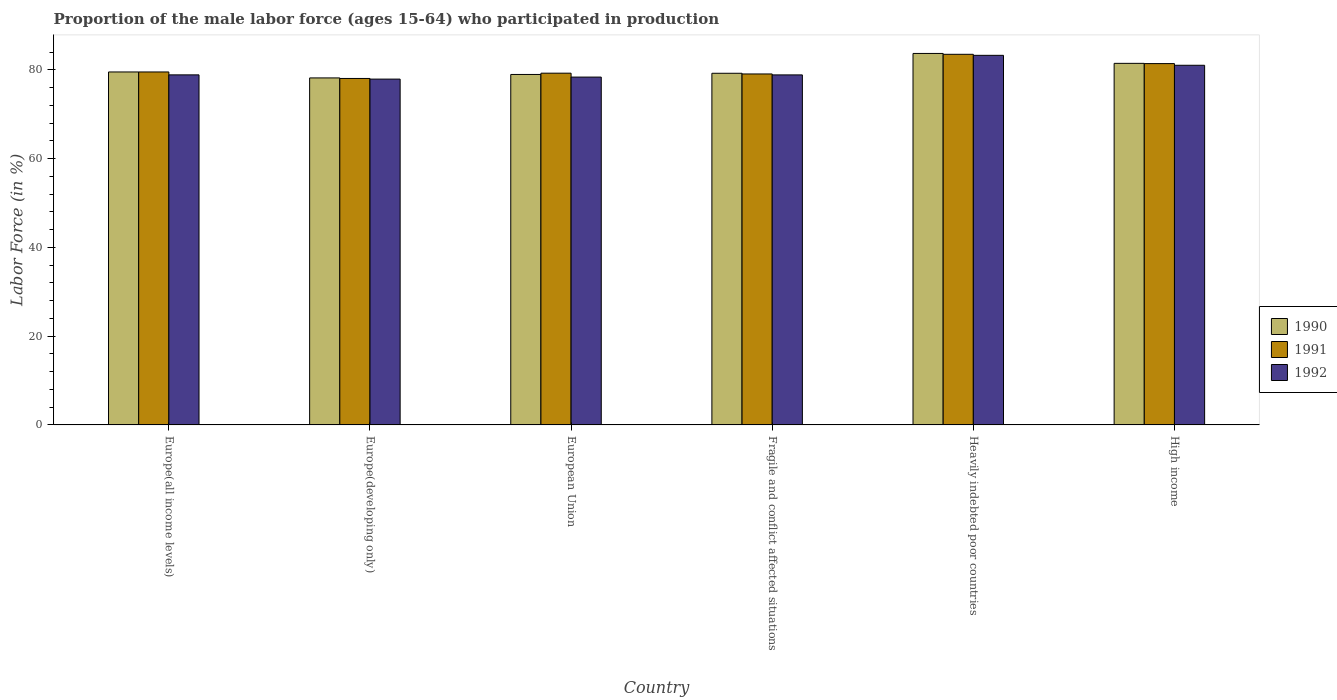Are the number of bars on each tick of the X-axis equal?
Ensure brevity in your answer.  Yes. What is the label of the 1st group of bars from the left?
Offer a very short reply. Europe(all income levels). What is the proportion of the male labor force who participated in production in 1991 in High income?
Your answer should be very brief. 81.39. Across all countries, what is the maximum proportion of the male labor force who participated in production in 1991?
Your answer should be very brief. 83.49. Across all countries, what is the minimum proportion of the male labor force who participated in production in 1992?
Give a very brief answer. 77.9. In which country was the proportion of the male labor force who participated in production in 1991 maximum?
Your response must be concise. Heavily indebted poor countries. In which country was the proportion of the male labor force who participated in production in 1991 minimum?
Your answer should be compact. Europe(developing only). What is the total proportion of the male labor force who participated in production in 1992 in the graph?
Keep it short and to the point. 478.23. What is the difference between the proportion of the male labor force who participated in production in 1990 in Europe(developing only) and that in European Union?
Your answer should be compact. -0.78. What is the difference between the proportion of the male labor force who participated in production in 1991 in Fragile and conflict affected situations and the proportion of the male labor force who participated in production in 1990 in Europe(all income levels)?
Your answer should be compact. -0.45. What is the average proportion of the male labor force who participated in production in 1991 per country?
Your answer should be compact. 80.12. What is the difference between the proportion of the male labor force who participated in production of/in 1991 and proportion of the male labor force who participated in production of/in 1992 in High income?
Provide a short and direct response. 0.38. What is the ratio of the proportion of the male labor force who participated in production in 1991 in European Union to that in Heavily indebted poor countries?
Your answer should be very brief. 0.95. What is the difference between the highest and the second highest proportion of the male labor force who participated in production in 1991?
Offer a very short reply. -2.09. What is the difference between the highest and the lowest proportion of the male labor force who participated in production in 1990?
Give a very brief answer. 5.51. Is the sum of the proportion of the male labor force who participated in production in 1991 in Europe(developing only) and High income greater than the maximum proportion of the male labor force who participated in production in 1992 across all countries?
Your answer should be very brief. Yes. What does the 2nd bar from the left in High income represents?
Keep it short and to the point. 1991. What does the 1st bar from the right in Europe(developing only) represents?
Make the answer very short. 1992. Is it the case that in every country, the sum of the proportion of the male labor force who participated in production in 1991 and proportion of the male labor force who participated in production in 1990 is greater than the proportion of the male labor force who participated in production in 1992?
Offer a terse response. Yes. How many bars are there?
Keep it short and to the point. 18. How many countries are there in the graph?
Offer a very short reply. 6. What is the difference between two consecutive major ticks on the Y-axis?
Keep it short and to the point. 20. Does the graph contain any zero values?
Offer a terse response. No. How many legend labels are there?
Your response must be concise. 3. How are the legend labels stacked?
Ensure brevity in your answer.  Vertical. What is the title of the graph?
Give a very brief answer. Proportion of the male labor force (ages 15-64) who participated in production. Does "1969" appear as one of the legend labels in the graph?
Your response must be concise. No. What is the Labor Force (in %) in 1990 in Europe(all income levels)?
Offer a very short reply. 79.51. What is the Labor Force (in %) in 1991 in Europe(all income levels)?
Your answer should be compact. 79.51. What is the Labor Force (in %) in 1992 in Europe(all income levels)?
Keep it short and to the point. 78.85. What is the Labor Force (in %) of 1990 in Europe(developing only)?
Keep it short and to the point. 78.17. What is the Labor Force (in %) in 1991 in Europe(developing only)?
Your answer should be very brief. 78.05. What is the Labor Force (in %) of 1992 in Europe(developing only)?
Keep it short and to the point. 77.9. What is the Labor Force (in %) of 1990 in European Union?
Your response must be concise. 78.95. What is the Labor Force (in %) of 1991 in European Union?
Your answer should be very brief. 79.24. What is the Labor Force (in %) in 1992 in European Union?
Offer a terse response. 78.36. What is the Labor Force (in %) of 1990 in Fragile and conflict affected situations?
Give a very brief answer. 79.22. What is the Labor Force (in %) in 1991 in Fragile and conflict affected situations?
Provide a succinct answer. 79.06. What is the Labor Force (in %) of 1992 in Fragile and conflict affected situations?
Offer a terse response. 78.85. What is the Labor Force (in %) in 1990 in Heavily indebted poor countries?
Ensure brevity in your answer.  83.68. What is the Labor Force (in %) of 1991 in Heavily indebted poor countries?
Offer a very short reply. 83.49. What is the Labor Force (in %) of 1992 in Heavily indebted poor countries?
Offer a terse response. 83.25. What is the Labor Force (in %) of 1990 in High income?
Give a very brief answer. 81.45. What is the Labor Force (in %) in 1991 in High income?
Your response must be concise. 81.39. What is the Labor Force (in %) in 1992 in High income?
Your response must be concise. 81.02. Across all countries, what is the maximum Labor Force (in %) in 1990?
Provide a succinct answer. 83.68. Across all countries, what is the maximum Labor Force (in %) in 1991?
Your answer should be very brief. 83.49. Across all countries, what is the maximum Labor Force (in %) in 1992?
Offer a very short reply. 83.25. Across all countries, what is the minimum Labor Force (in %) of 1990?
Keep it short and to the point. 78.17. Across all countries, what is the minimum Labor Force (in %) of 1991?
Your answer should be compact. 78.05. Across all countries, what is the minimum Labor Force (in %) of 1992?
Provide a succinct answer. 77.9. What is the total Labor Force (in %) in 1990 in the graph?
Your response must be concise. 480.98. What is the total Labor Force (in %) in 1991 in the graph?
Ensure brevity in your answer.  480.74. What is the total Labor Force (in %) in 1992 in the graph?
Ensure brevity in your answer.  478.23. What is the difference between the Labor Force (in %) in 1990 in Europe(all income levels) and that in Europe(developing only)?
Provide a short and direct response. 1.34. What is the difference between the Labor Force (in %) of 1991 in Europe(all income levels) and that in Europe(developing only)?
Your response must be concise. 1.46. What is the difference between the Labor Force (in %) of 1992 in Europe(all income levels) and that in Europe(developing only)?
Provide a short and direct response. 0.95. What is the difference between the Labor Force (in %) of 1990 in Europe(all income levels) and that in European Union?
Keep it short and to the point. 0.56. What is the difference between the Labor Force (in %) of 1991 in Europe(all income levels) and that in European Union?
Offer a very short reply. 0.27. What is the difference between the Labor Force (in %) in 1992 in Europe(all income levels) and that in European Union?
Keep it short and to the point. 0.5. What is the difference between the Labor Force (in %) in 1990 in Europe(all income levels) and that in Fragile and conflict affected situations?
Make the answer very short. 0.3. What is the difference between the Labor Force (in %) in 1991 in Europe(all income levels) and that in Fragile and conflict affected situations?
Your answer should be compact. 0.45. What is the difference between the Labor Force (in %) of 1992 in Europe(all income levels) and that in Fragile and conflict affected situations?
Provide a short and direct response. 0.01. What is the difference between the Labor Force (in %) in 1990 in Europe(all income levels) and that in Heavily indebted poor countries?
Provide a short and direct response. -4.17. What is the difference between the Labor Force (in %) of 1991 in Europe(all income levels) and that in Heavily indebted poor countries?
Offer a very short reply. -3.98. What is the difference between the Labor Force (in %) in 1992 in Europe(all income levels) and that in Heavily indebted poor countries?
Give a very brief answer. -4.4. What is the difference between the Labor Force (in %) of 1990 in Europe(all income levels) and that in High income?
Give a very brief answer. -1.94. What is the difference between the Labor Force (in %) of 1991 in Europe(all income levels) and that in High income?
Offer a terse response. -1.89. What is the difference between the Labor Force (in %) in 1992 in Europe(all income levels) and that in High income?
Provide a short and direct response. -2.16. What is the difference between the Labor Force (in %) in 1990 in Europe(developing only) and that in European Union?
Provide a succinct answer. -0.78. What is the difference between the Labor Force (in %) of 1991 in Europe(developing only) and that in European Union?
Your answer should be compact. -1.19. What is the difference between the Labor Force (in %) of 1992 in Europe(developing only) and that in European Union?
Ensure brevity in your answer.  -0.45. What is the difference between the Labor Force (in %) in 1990 in Europe(developing only) and that in Fragile and conflict affected situations?
Make the answer very short. -1.05. What is the difference between the Labor Force (in %) in 1991 in Europe(developing only) and that in Fragile and conflict affected situations?
Offer a terse response. -1.01. What is the difference between the Labor Force (in %) in 1992 in Europe(developing only) and that in Fragile and conflict affected situations?
Ensure brevity in your answer.  -0.94. What is the difference between the Labor Force (in %) in 1990 in Europe(developing only) and that in Heavily indebted poor countries?
Offer a very short reply. -5.51. What is the difference between the Labor Force (in %) in 1991 in Europe(developing only) and that in Heavily indebted poor countries?
Your response must be concise. -5.44. What is the difference between the Labor Force (in %) in 1992 in Europe(developing only) and that in Heavily indebted poor countries?
Keep it short and to the point. -5.35. What is the difference between the Labor Force (in %) of 1990 in Europe(developing only) and that in High income?
Your answer should be compact. -3.28. What is the difference between the Labor Force (in %) of 1991 in Europe(developing only) and that in High income?
Provide a short and direct response. -3.35. What is the difference between the Labor Force (in %) in 1992 in Europe(developing only) and that in High income?
Keep it short and to the point. -3.11. What is the difference between the Labor Force (in %) in 1990 in European Union and that in Fragile and conflict affected situations?
Make the answer very short. -0.27. What is the difference between the Labor Force (in %) in 1991 in European Union and that in Fragile and conflict affected situations?
Offer a very short reply. 0.18. What is the difference between the Labor Force (in %) of 1992 in European Union and that in Fragile and conflict affected situations?
Ensure brevity in your answer.  -0.49. What is the difference between the Labor Force (in %) in 1990 in European Union and that in Heavily indebted poor countries?
Offer a terse response. -4.73. What is the difference between the Labor Force (in %) in 1991 in European Union and that in Heavily indebted poor countries?
Give a very brief answer. -4.25. What is the difference between the Labor Force (in %) of 1992 in European Union and that in Heavily indebted poor countries?
Provide a short and direct response. -4.9. What is the difference between the Labor Force (in %) in 1990 in European Union and that in High income?
Provide a succinct answer. -2.5. What is the difference between the Labor Force (in %) in 1991 in European Union and that in High income?
Offer a terse response. -2.16. What is the difference between the Labor Force (in %) of 1992 in European Union and that in High income?
Keep it short and to the point. -2.66. What is the difference between the Labor Force (in %) in 1990 in Fragile and conflict affected situations and that in Heavily indebted poor countries?
Your response must be concise. -4.47. What is the difference between the Labor Force (in %) of 1991 in Fragile and conflict affected situations and that in Heavily indebted poor countries?
Your response must be concise. -4.43. What is the difference between the Labor Force (in %) in 1992 in Fragile and conflict affected situations and that in Heavily indebted poor countries?
Offer a terse response. -4.41. What is the difference between the Labor Force (in %) in 1990 in Fragile and conflict affected situations and that in High income?
Provide a succinct answer. -2.24. What is the difference between the Labor Force (in %) of 1991 in Fragile and conflict affected situations and that in High income?
Your answer should be very brief. -2.33. What is the difference between the Labor Force (in %) in 1992 in Fragile and conflict affected situations and that in High income?
Your response must be concise. -2.17. What is the difference between the Labor Force (in %) in 1990 in Heavily indebted poor countries and that in High income?
Offer a terse response. 2.23. What is the difference between the Labor Force (in %) of 1991 in Heavily indebted poor countries and that in High income?
Provide a succinct answer. 2.09. What is the difference between the Labor Force (in %) in 1992 in Heavily indebted poor countries and that in High income?
Your answer should be compact. 2.24. What is the difference between the Labor Force (in %) of 1990 in Europe(all income levels) and the Labor Force (in %) of 1991 in Europe(developing only)?
Provide a succinct answer. 1.46. What is the difference between the Labor Force (in %) of 1990 in Europe(all income levels) and the Labor Force (in %) of 1992 in Europe(developing only)?
Give a very brief answer. 1.61. What is the difference between the Labor Force (in %) of 1991 in Europe(all income levels) and the Labor Force (in %) of 1992 in Europe(developing only)?
Ensure brevity in your answer.  1.61. What is the difference between the Labor Force (in %) in 1990 in Europe(all income levels) and the Labor Force (in %) in 1991 in European Union?
Offer a very short reply. 0.27. What is the difference between the Labor Force (in %) of 1990 in Europe(all income levels) and the Labor Force (in %) of 1992 in European Union?
Keep it short and to the point. 1.15. What is the difference between the Labor Force (in %) of 1991 in Europe(all income levels) and the Labor Force (in %) of 1992 in European Union?
Ensure brevity in your answer.  1.15. What is the difference between the Labor Force (in %) in 1990 in Europe(all income levels) and the Labor Force (in %) in 1991 in Fragile and conflict affected situations?
Provide a succinct answer. 0.45. What is the difference between the Labor Force (in %) in 1990 in Europe(all income levels) and the Labor Force (in %) in 1992 in Fragile and conflict affected situations?
Offer a very short reply. 0.66. What is the difference between the Labor Force (in %) of 1991 in Europe(all income levels) and the Labor Force (in %) of 1992 in Fragile and conflict affected situations?
Provide a short and direct response. 0.66. What is the difference between the Labor Force (in %) of 1990 in Europe(all income levels) and the Labor Force (in %) of 1991 in Heavily indebted poor countries?
Offer a terse response. -3.98. What is the difference between the Labor Force (in %) in 1990 in Europe(all income levels) and the Labor Force (in %) in 1992 in Heavily indebted poor countries?
Your answer should be very brief. -3.74. What is the difference between the Labor Force (in %) of 1991 in Europe(all income levels) and the Labor Force (in %) of 1992 in Heavily indebted poor countries?
Provide a short and direct response. -3.75. What is the difference between the Labor Force (in %) in 1990 in Europe(all income levels) and the Labor Force (in %) in 1991 in High income?
Your answer should be compact. -1.88. What is the difference between the Labor Force (in %) in 1990 in Europe(all income levels) and the Labor Force (in %) in 1992 in High income?
Offer a very short reply. -1.5. What is the difference between the Labor Force (in %) in 1991 in Europe(all income levels) and the Labor Force (in %) in 1992 in High income?
Make the answer very short. -1.51. What is the difference between the Labor Force (in %) in 1990 in Europe(developing only) and the Labor Force (in %) in 1991 in European Union?
Keep it short and to the point. -1.07. What is the difference between the Labor Force (in %) of 1990 in Europe(developing only) and the Labor Force (in %) of 1992 in European Union?
Make the answer very short. -0.19. What is the difference between the Labor Force (in %) of 1991 in Europe(developing only) and the Labor Force (in %) of 1992 in European Union?
Your answer should be very brief. -0.31. What is the difference between the Labor Force (in %) in 1990 in Europe(developing only) and the Labor Force (in %) in 1991 in Fragile and conflict affected situations?
Give a very brief answer. -0.89. What is the difference between the Labor Force (in %) in 1990 in Europe(developing only) and the Labor Force (in %) in 1992 in Fragile and conflict affected situations?
Offer a terse response. -0.68. What is the difference between the Labor Force (in %) of 1991 in Europe(developing only) and the Labor Force (in %) of 1992 in Fragile and conflict affected situations?
Ensure brevity in your answer.  -0.8. What is the difference between the Labor Force (in %) of 1990 in Europe(developing only) and the Labor Force (in %) of 1991 in Heavily indebted poor countries?
Your answer should be very brief. -5.32. What is the difference between the Labor Force (in %) in 1990 in Europe(developing only) and the Labor Force (in %) in 1992 in Heavily indebted poor countries?
Provide a short and direct response. -5.08. What is the difference between the Labor Force (in %) of 1991 in Europe(developing only) and the Labor Force (in %) of 1992 in Heavily indebted poor countries?
Provide a succinct answer. -5.21. What is the difference between the Labor Force (in %) in 1990 in Europe(developing only) and the Labor Force (in %) in 1991 in High income?
Your response must be concise. -3.22. What is the difference between the Labor Force (in %) in 1990 in Europe(developing only) and the Labor Force (in %) in 1992 in High income?
Your answer should be compact. -2.84. What is the difference between the Labor Force (in %) of 1991 in Europe(developing only) and the Labor Force (in %) of 1992 in High income?
Your response must be concise. -2.97. What is the difference between the Labor Force (in %) in 1990 in European Union and the Labor Force (in %) in 1991 in Fragile and conflict affected situations?
Your response must be concise. -0.11. What is the difference between the Labor Force (in %) of 1990 in European Union and the Labor Force (in %) of 1992 in Fragile and conflict affected situations?
Ensure brevity in your answer.  0.1. What is the difference between the Labor Force (in %) of 1991 in European Union and the Labor Force (in %) of 1992 in Fragile and conflict affected situations?
Offer a terse response. 0.39. What is the difference between the Labor Force (in %) of 1990 in European Union and the Labor Force (in %) of 1991 in Heavily indebted poor countries?
Provide a succinct answer. -4.54. What is the difference between the Labor Force (in %) in 1990 in European Union and the Labor Force (in %) in 1992 in Heavily indebted poor countries?
Provide a succinct answer. -4.31. What is the difference between the Labor Force (in %) of 1991 in European Union and the Labor Force (in %) of 1992 in Heavily indebted poor countries?
Offer a terse response. -4.02. What is the difference between the Labor Force (in %) in 1990 in European Union and the Labor Force (in %) in 1991 in High income?
Your answer should be very brief. -2.45. What is the difference between the Labor Force (in %) in 1990 in European Union and the Labor Force (in %) in 1992 in High income?
Offer a terse response. -2.07. What is the difference between the Labor Force (in %) of 1991 in European Union and the Labor Force (in %) of 1992 in High income?
Ensure brevity in your answer.  -1.78. What is the difference between the Labor Force (in %) of 1990 in Fragile and conflict affected situations and the Labor Force (in %) of 1991 in Heavily indebted poor countries?
Make the answer very short. -4.27. What is the difference between the Labor Force (in %) in 1990 in Fragile and conflict affected situations and the Labor Force (in %) in 1992 in Heavily indebted poor countries?
Keep it short and to the point. -4.04. What is the difference between the Labor Force (in %) of 1991 in Fragile and conflict affected situations and the Labor Force (in %) of 1992 in Heavily indebted poor countries?
Your answer should be compact. -4.19. What is the difference between the Labor Force (in %) in 1990 in Fragile and conflict affected situations and the Labor Force (in %) in 1991 in High income?
Keep it short and to the point. -2.18. What is the difference between the Labor Force (in %) of 1990 in Fragile and conflict affected situations and the Labor Force (in %) of 1992 in High income?
Provide a short and direct response. -1.8. What is the difference between the Labor Force (in %) of 1991 in Fragile and conflict affected situations and the Labor Force (in %) of 1992 in High income?
Provide a succinct answer. -1.96. What is the difference between the Labor Force (in %) of 1990 in Heavily indebted poor countries and the Labor Force (in %) of 1991 in High income?
Keep it short and to the point. 2.29. What is the difference between the Labor Force (in %) in 1990 in Heavily indebted poor countries and the Labor Force (in %) in 1992 in High income?
Ensure brevity in your answer.  2.67. What is the difference between the Labor Force (in %) of 1991 in Heavily indebted poor countries and the Labor Force (in %) of 1992 in High income?
Keep it short and to the point. 2.47. What is the average Labor Force (in %) in 1990 per country?
Offer a very short reply. 80.16. What is the average Labor Force (in %) of 1991 per country?
Your answer should be very brief. 80.12. What is the average Labor Force (in %) in 1992 per country?
Offer a very short reply. 79.71. What is the difference between the Labor Force (in %) in 1990 and Labor Force (in %) in 1991 in Europe(all income levels)?
Offer a terse response. 0. What is the difference between the Labor Force (in %) in 1990 and Labor Force (in %) in 1992 in Europe(all income levels)?
Provide a succinct answer. 0.66. What is the difference between the Labor Force (in %) of 1991 and Labor Force (in %) of 1992 in Europe(all income levels)?
Offer a terse response. 0.65. What is the difference between the Labor Force (in %) of 1990 and Labor Force (in %) of 1991 in Europe(developing only)?
Provide a succinct answer. 0.12. What is the difference between the Labor Force (in %) of 1990 and Labor Force (in %) of 1992 in Europe(developing only)?
Give a very brief answer. 0.27. What is the difference between the Labor Force (in %) in 1991 and Labor Force (in %) in 1992 in Europe(developing only)?
Provide a short and direct response. 0.14. What is the difference between the Labor Force (in %) of 1990 and Labor Force (in %) of 1991 in European Union?
Your answer should be very brief. -0.29. What is the difference between the Labor Force (in %) of 1990 and Labor Force (in %) of 1992 in European Union?
Ensure brevity in your answer.  0.59. What is the difference between the Labor Force (in %) in 1991 and Labor Force (in %) in 1992 in European Union?
Make the answer very short. 0.88. What is the difference between the Labor Force (in %) in 1990 and Labor Force (in %) in 1991 in Fragile and conflict affected situations?
Your answer should be very brief. 0.16. What is the difference between the Labor Force (in %) of 1990 and Labor Force (in %) of 1992 in Fragile and conflict affected situations?
Your answer should be very brief. 0.37. What is the difference between the Labor Force (in %) in 1991 and Labor Force (in %) in 1992 in Fragile and conflict affected situations?
Provide a succinct answer. 0.21. What is the difference between the Labor Force (in %) of 1990 and Labor Force (in %) of 1991 in Heavily indebted poor countries?
Keep it short and to the point. 0.19. What is the difference between the Labor Force (in %) of 1990 and Labor Force (in %) of 1992 in Heavily indebted poor countries?
Your answer should be very brief. 0.43. What is the difference between the Labor Force (in %) in 1991 and Labor Force (in %) in 1992 in Heavily indebted poor countries?
Your answer should be compact. 0.23. What is the difference between the Labor Force (in %) of 1990 and Labor Force (in %) of 1991 in High income?
Your answer should be compact. 0.06. What is the difference between the Labor Force (in %) of 1990 and Labor Force (in %) of 1992 in High income?
Provide a succinct answer. 0.44. What is the difference between the Labor Force (in %) in 1991 and Labor Force (in %) in 1992 in High income?
Your answer should be very brief. 0.38. What is the ratio of the Labor Force (in %) of 1990 in Europe(all income levels) to that in Europe(developing only)?
Your answer should be very brief. 1.02. What is the ratio of the Labor Force (in %) in 1991 in Europe(all income levels) to that in Europe(developing only)?
Provide a short and direct response. 1.02. What is the ratio of the Labor Force (in %) of 1992 in Europe(all income levels) to that in Europe(developing only)?
Make the answer very short. 1.01. What is the ratio of the Labor Force (in %) of 1990 in Europe(all income levels) to that in European Union?
Give a very brief answer. 1.01. What is the ratio of the Labor Force (in %) of 1991 in Europe(all income levels) to that in European Union?
Give a very brief answer. 1. What is the ratio of the Labor Force (in %) of 1990 in Europe(all income levels) to that in Fragile and conflict affected situations?
Keep it short and to the point. 1. What is the ratio of the Labor Force (in %) in 1990 in Europe(all income levels) to that in Heavily indebted poor countries?
Give a very brief answer. 0.95. What is the ratio of the Labor Force (in %) of 1991 in Europe(all income levels) to that in Heavily indebted poor countries?
Keep it short and to the point. 0.95. What is the ratio of the Labor Force (in %) of 1992 in Europe(all income levels) to that in Heavily indebted poor countries?
Keep it short and to the point. 0.95. What is the ratio of the Labor Force (in %) in 1990 in Europe(all income levels) to that in High income?
Keep it short and to the point. 0.98. What is the ratio of the Labor Force (in %) of 1991 in Europe(all income levels) to that in High income?
Provide a short and direct response. 0.98. What is the ratio of the Labor Force (in %) in 1992 in Europe(all income levels) to that in High income?
Your answer should be compact. 0.97. What is the ratio of the Labor Force (in %) of 1991 in Europe(developing only) to that in European Union?
Keep it short and to the point. 0.98. What is the ratio of the Labor Force (in %) in 1990 in Europe(developing only) to that in Fragile and conflict affected situations?
Offer a terse response. 0.99. What is the ratio of the Labor Force (in %) of 1991 in Europe(developing only) to that in Fragile and conflict affected situations?
Offer a very short reply. 0.99. What is the ratio of the Labor Force (in %) of 1990 in Europe(developing only) to that in Heavily indebted poor countries?
Provide a succinct answer. 0.93. What is the ratio of the Labor Force (in %) in 1991 in Europe(developing only) to that in Heavily indebted poor countries?
Ensure brevity in your answer.  0.93. What is the ratio of the Labor Force (in %) of 1992 in Europe(developing only) to that in Heavily indebted poor countries?
Offer a terse response. 0.94. What is the ratio of the Labor Force (in %) of 1990 in Europe(developing only) to that in High income?
Offer a very short reply. 0.96. What is the ratio of the Labor Force (in %) in 1991 in Europe(developing only) to that in High income?
Provide a short and direct response. 0.96. What is the ratio of the Labor Force (in %) of 1992 in Europe(developing only) to that in High income?
Your answer should be very brief. 0.96. What is the ratio of the Labor Force (in %) in 1990 in European Union to that in Heavily indebted poor countries?
Make the answer very short. 0.94. What is the ratio of the Labor Force (in %) of 1991 in European Union to that in Heavily indebted poor countries?
Offer a very short reply. 0.95. What is the ratio of the Labor Force (in %) in 1992 in European Union to that in Heavily indebted poor countries?
Keep it short and to the point. 0.94. What is the ratio of the Labor Force (in %) of 1990 in European Union to that in High income?
Your answer should be compact. 0.97. What is the ratio of the Labor Force (in %) in 1991 in European Union to that in High income?
Your answer should be very brief. 0.97. What is the ratio of the Labor Force (in %) in 1992 in European Union to that in High income?
Your answer should be very brief. 0.97. What is the ratio of the Labor Force (in %) in 1990 in Fragile and conflict affected situations to that in Heavily indebted poor countries?
Your response must be concise. 0.95. What is the ratio of the Labor Force (in %) of 1991 in Fragile and conflict affected situations to that in Heavily indebted poor countries?
Offer a terse response. 0.95. What is the ratio of the Labor Force (in %) in 1992 in Fragile and conflict affected situations to that in Heavily indebted poor countries?
Your response must be concise. 0.95. What is the ratio of the Labor Force (in %) of 1990 in Fragile and conflict affected situations to that in High income?
Provide a succinct answer. 0.97. What is the ratio of the Labor Force (in %) in 1991 in Fragile and conflict affected situations to that in High income?
Make the answer very short. 0.97. What is the ratio of the Labor Force (in %) of 1992 in Fragile and conflict affected situations to that in High income?
Offer a very short reply. 0.97. What is the ratio of the Labor Force (in %) of 1990 in Heavily indebted poor countries to that in High income?
Offer a terse response. 1.03. What is the ratio of the Labor Force (in %) of 1991 in Heavily indebted poor countries to that in High income?
Offer a terse response. 1.03. What is the ratio of the Labor Force (in %) of 1992 in Heavily indebted poor countries to that in High income?
Your answer should be very brief. 1.03. What is the difference between the highest and the second highest Labor Force (in %) of 1990?
Provide a short and direct response. 2.23. What is the difference between the highest and the second highest Labor Force (in %) in 1991?
Offer a very short reply. 2.09. What is the difference between the highest and the second highest Labor Force (in %) of 1992?
Provide a short and direct response. 2.24. What is the difference between the highest and the lowest Labor Force (in %) of 1990?
Offer a very short reply. 5.51. What is the difference between the highest and the lowest Labor Force (in %) in 1991?
Offer a terse response. 5.44. What is the difference between the highest and the lowest Labor Force (in %) in 1992?
Make the answer very short. 5.35. 